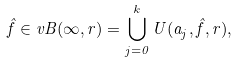<formula> <loc_0><loc_0><loc_500><loc_500>\hat { f } \in v B ( \infty , r ) = \bigcup _ { j = 0 } ^ { k } U ( a _ { j } , \hat { f } , r ) ,</formula> 